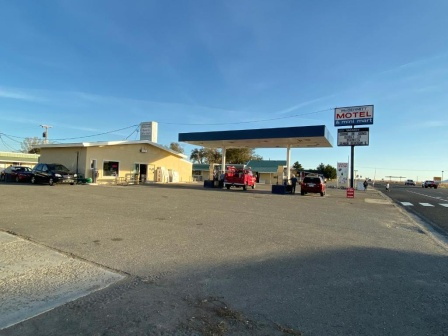Can you guess what time of day it is based on this image? The strong shadows cast on the ground and the quality of the light suggest it's either early morning or late afternoon. Based on the length and direction of the shadows, which appear to be relatively short and directed eastward, it's likely early morning. 